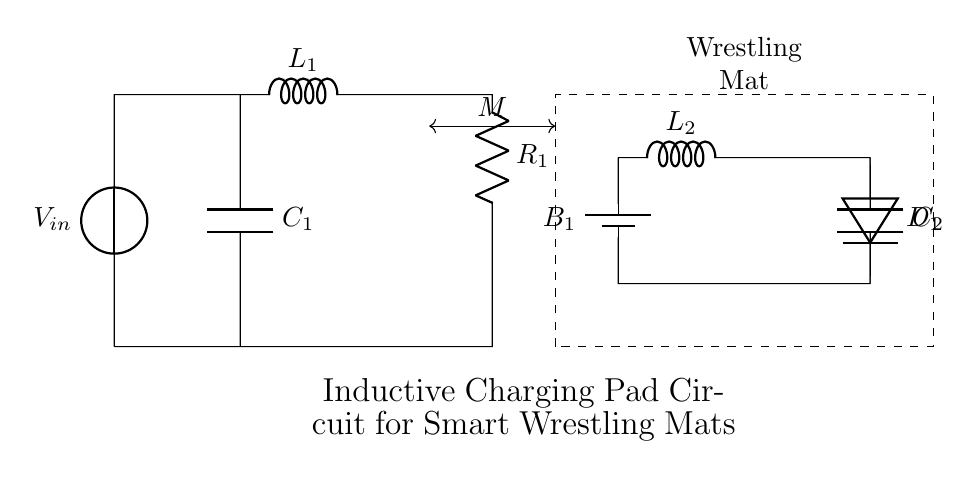What is the component labeled L1? L1 is labeled as an inductor in the circuit, which stores energy in a magnetic field when current flows through it.
Answer: Inductor What is the purpose of the capacitor C1? C1 is used for filtering or smoothing the voltage in the circuit, helping to stabilize the output.
Answer: Smoothing What is the role of the battery B1 in this circuit? B1 serves as the power source that provides the necessary voltage to the wrestling mat's secondary circuit.
Answer: Power source What is the value of the resistance R1? R1 is labeled as a resistor in the circuit, representing its resistance value; however, the exact numerical value is not provided in the diagram.
Answer: Not specified Which component provides the coupling between primary and secondary? The coupling between the primary and secondary circuits is represented by M, which refers to mutual inductance between L1 and L2.
Answer: Mutual inductance How many inductors are present in this circuit? There are two inductors illustrated in the circuit diagram: L1 in the primary circuit and L2 in the secondary circuit.
Answer: Two 